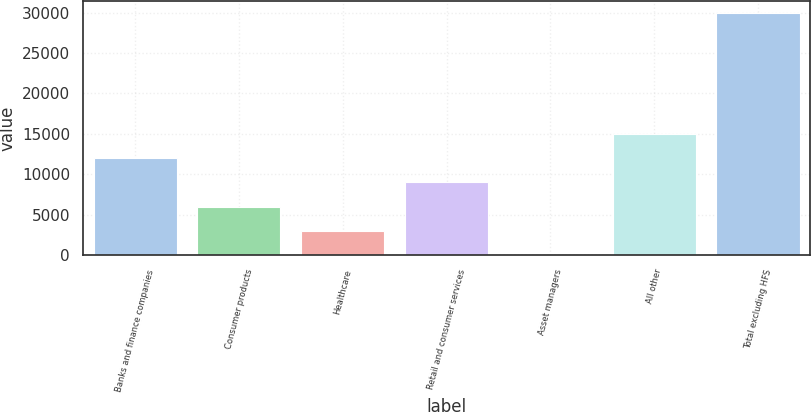Convert chart to OTSL. <chart><loc_0><loc_0><loc_500><loc_500><bar_chart><fcel>Banks and finance companies<fcel>Consumer products<fcel>Healthcare<fcel>Retail and consumer services<fcel>Asset managers<fcel>All other<fcel>Total excluding HFS<nl><fcel>11967.8<fcel>5996.4<fcel>3010.7<fcel>8982.1<fcel>25<fcel>14953.5<fcel>29882<nl></chart> 